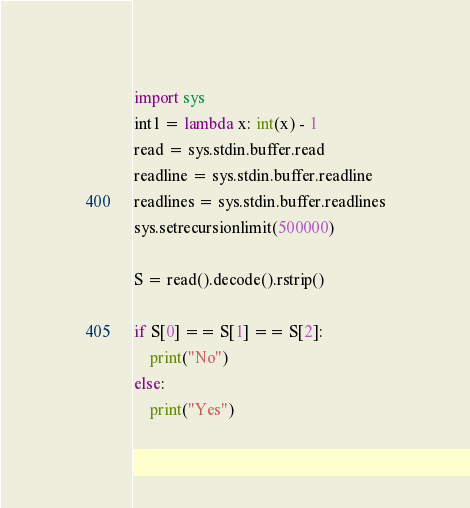<code> <loc_0><loc_0><loc_500><loc_500><_Python_>import sys
int1 = lambda x: int(x) - 1
read = sys.stdin.buffer.read
readline = sys.stdin.buffer.readline
readlines = sys.stdin.buffer.readlines
sys.setrecursionlimit(500000)

S = read().decode().rstrip()

if S[0] == S[1] == S[2]:
    print("No")
else:
    print("Yes")
</code> 